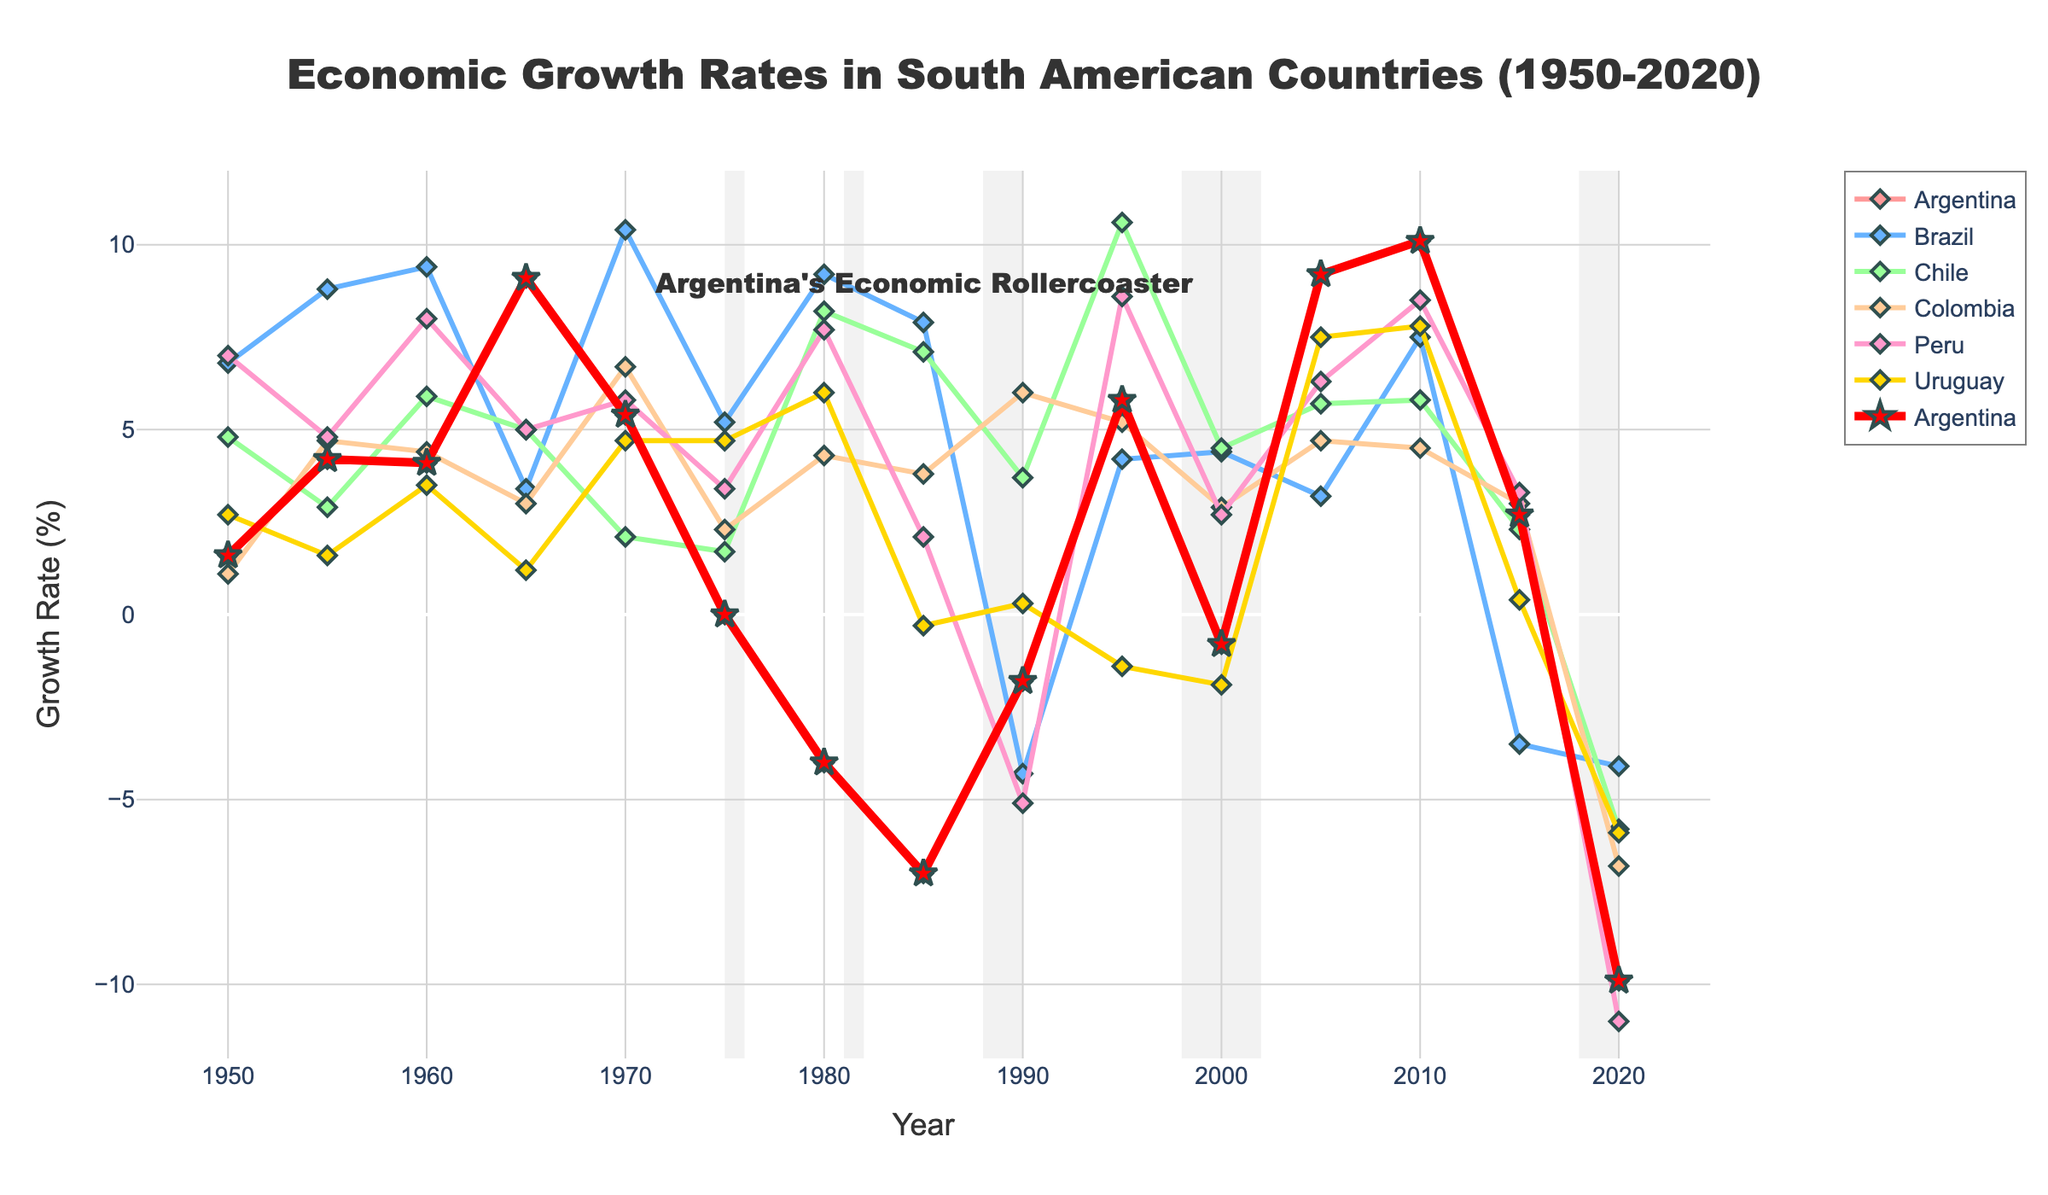What was the economic growth rate of Argentina in 1985? Look at the line representing Argentina in 1985. Locate the data point which is marked with a star on the red line. The y-axis value at this point is the growth rate.
Answer: -7.0 Was Argentina's economic growth rate ever higher than Chile's rate in the 2000s? Compare the lines for Argentina and Chile between the years 2000 and 2010. Look for points where Argentina's red line is above Chile's line. In 2005 and 2010, Argentina's growth rate was higher than Chile's.
Answer: Yes Which country had the highest economic growth rate in 2010? Locate the year 2010 on the x-axis and find the highest point among all lines. The peak point is from the red line representing Argentina.
Answer: Argentina What was the comparison of Argentina's growth rate to Uruguay's growth rate in the year 2020? Locate the year 2020 on the x-axis and compare the heights of the Argentina (red line with stars) and Uruguay (gold line with diamonds). Argentina's point is higher than Uruguay's.
Answer: Higher During which years did Argentina experience a positive economic growth rate, but Chile had a negative rate? Search for years when Argentina's red line is above zero, but Chile's line is below zero. In 1975, Argentina had a positive growth rate while Chile had a negative growth rate.
Answer: 1975 Which country had the most stable economic growth trend from 1950 to 2020? Look for the line that shows the least fluctuations over time. The yellow line representing Uruguay shows less fluctuation compared to others.
Answer: Uruguay 